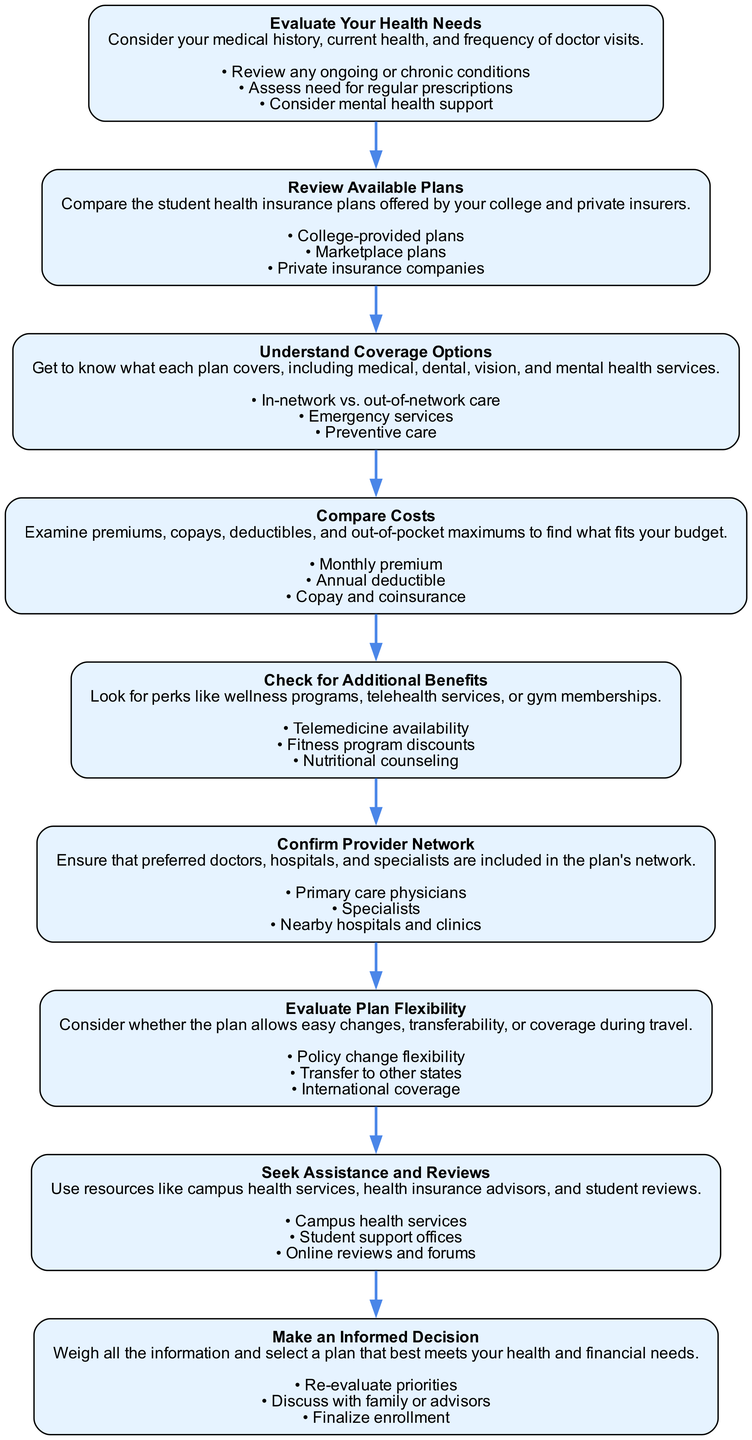What is the first step in the diagram? The diagram clearly lists "Evaluate Your Health Needs" as the first step. This can be found at the very top of the flow.
Answer: Evaluate Your Health Needs How many substeps are there under "Understand Coverage Options"? Under "Understand Coverage Options," there are three substeps listed: "In-network vs. out-of-network care," "Emergency services," and "Preventive care." Thus, the total is three.
Answer: 3 What are the additional benefits mentioned in the "Check for Additional Benefits" step? The substeps under "Check for Additional Benefits" include "Telemedicine availability," "Fitness program discounts," and "Nutritional counseling," which represent the additional benefits.
Answer: Telemedicine availability, Fitness program discounts, Nutritional counseling Which step follows "Compare Costs"? The step that follows "Compare Costs" is "Check for Additional Benefits." This is determined by looking at the sequence of steps that connect within the diagram.
Answer: Check for Additional Benefits What is the main focus of the "Make an Informed Decision" step? "Make an Informed Decision" focuses on weighing all the information and selecting a plan that best meets one’s health and financial needs. It's about the final evaluation and choice, emphasizing decision-making.
Answer: Weighing information and selecting a plan 